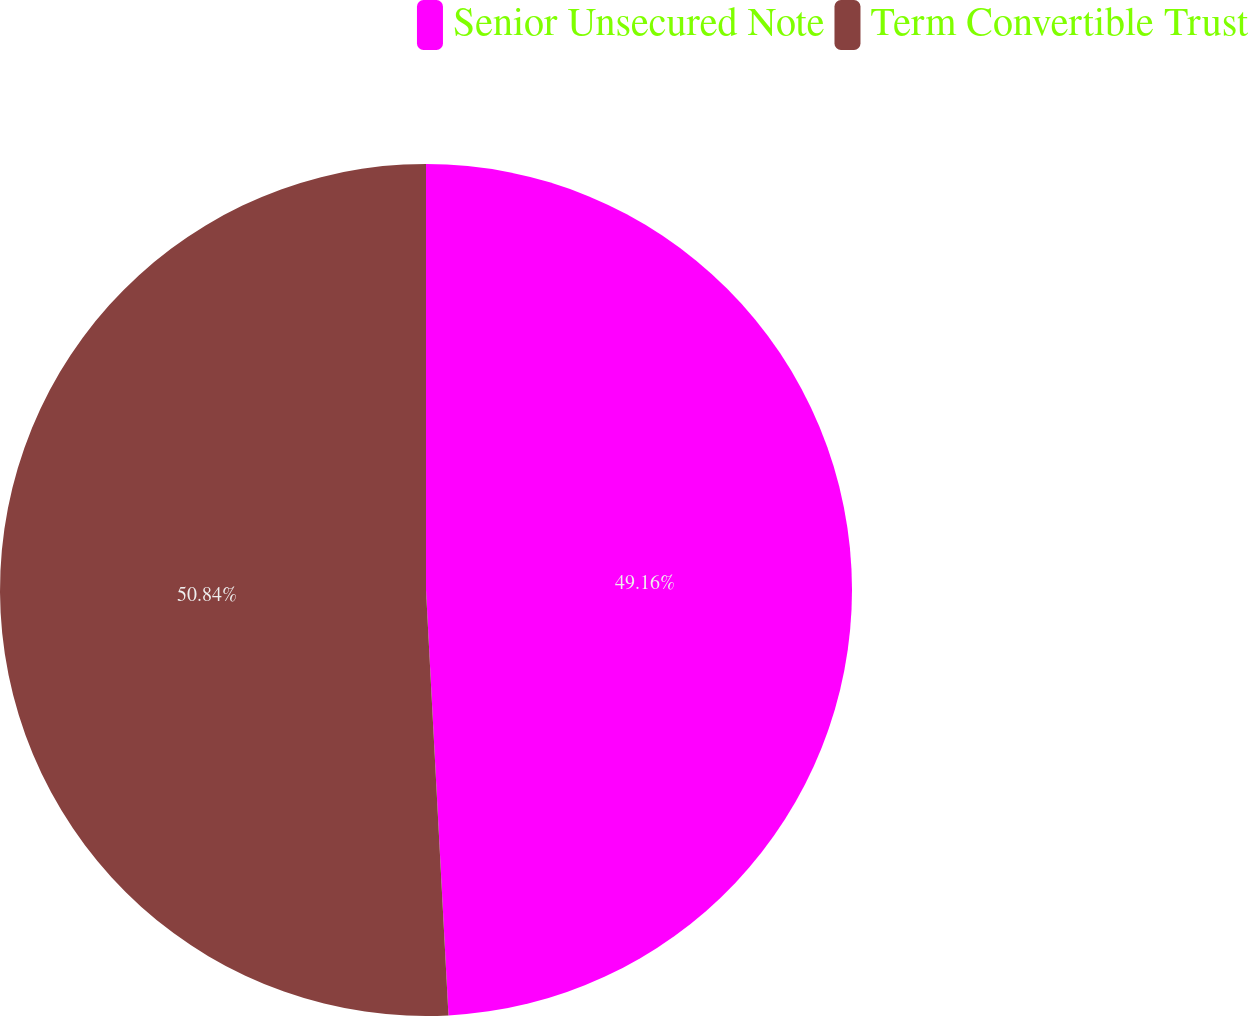<chart> <loc_0><loc_0><loc_500><loc_500><pie_chart><fcel>Senior Unsecured Note<fcel>Term Convertible Trust<nl><fcel>49.16%<fcel>50.84%<nl></chart> 